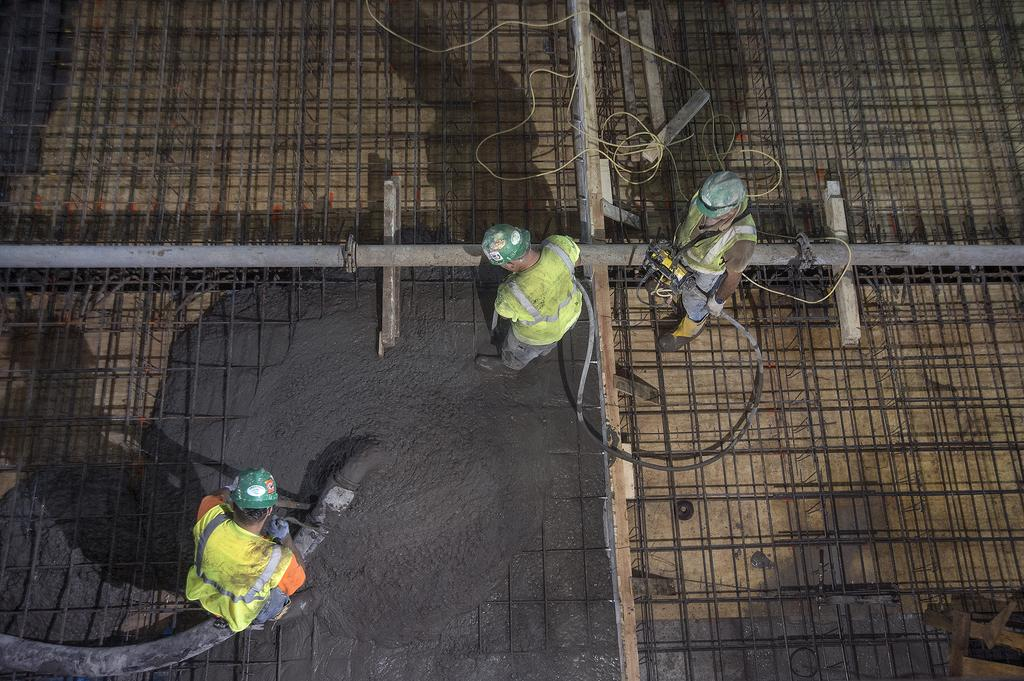How many people are in the image? There are three men in the image. What is one of the men holding? One man is holding a concrete pipe. What materials can be seen at the bottom of the image? Iron rods and concrete are present at the bottom of the image. What safety equipment are the men wearing? All men are wearing helmets. Is the ground made of quicksand in the image? No, there is no indication of quicksand in the image. Can you see a pickle in the hands of one of the men? No, there are no pickles present in the image. 